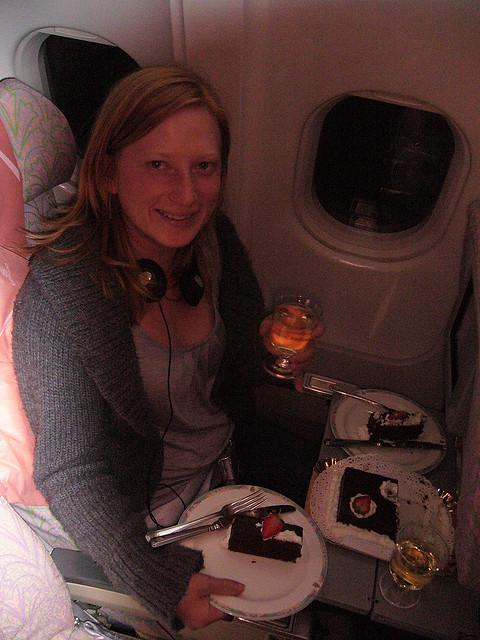Where is this woman feasting? Please explain your reasoning. airplane. The food is on a tray that is attached to the seat in front of the woman. the windows are small. 